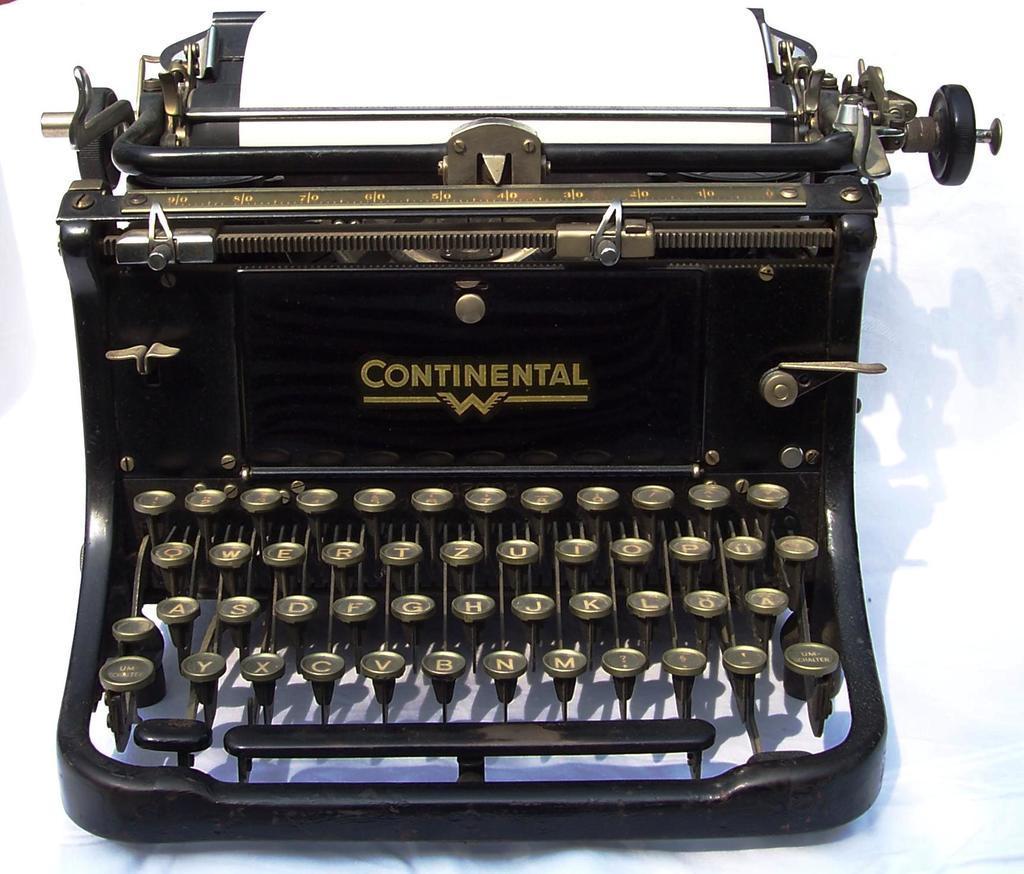Could you give a brief overview of what you see in this image? In this picture we can see old black typewriter on which "Continent"is written. Behind there is a white background. 